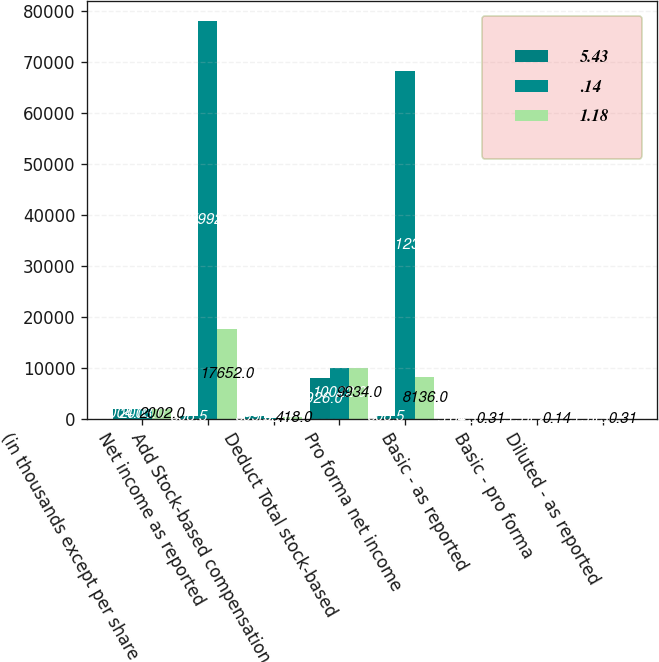<chart> <loc_0><loc_0><loc_500><loc_500><stacked_bar_chart><ecel><fcel>(in thousands except per share<fcel>Net income as reported<fcel>Add Stock-based compensation<fcel>Deduct Total stock-based<fcel>Pro forma net income<fcel>Basic - as reported<fcel>Basic - pro forma<fcel>Diluted - as reported<nl><fcel>5.43<fcel>2004<fcel>508.5<fcel>599<fcel>7926<fcel>508.5<fcel>5.64<fcel>5.51<fcel>5.55<nl><fcel>0.14<fcel>2003<fcel>77992<fcel>153<fcel>10022<fcel>68123<fcel>1.37<fcel>1.2<fcel>1.36<nl><fcel>1.18<fcel>2002<fcel>17652<fcel>418<fcel>9934<fcel>8136<fcel>0.31<fcel>0.14<fcel>0.31<nl></chart> 